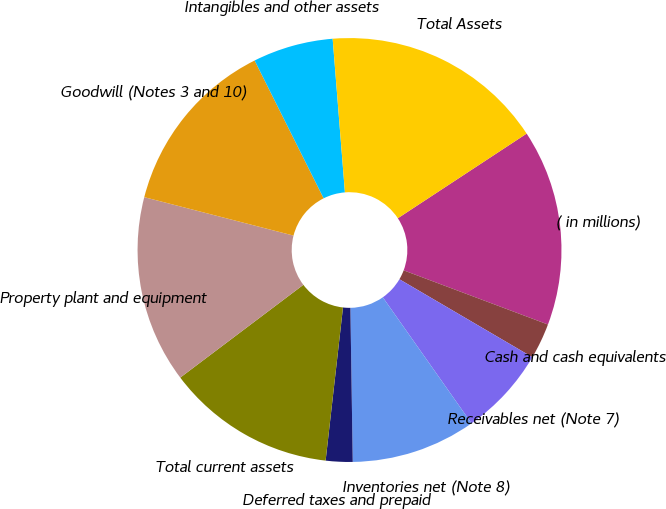<chart> <loc_0><loc_0><loc_500><loc_500><pie_chart><fcel>( in millions)<fcel>Cash and cash equivalents<fcel>Receivables net (Note 7)<fcel>Inventories net (Note 8)<fcel>Deferred taxes and prepaid<fcel>Total current assets<fcel>Property plant and equipment<fcel>Goodwill (Notes 3 and 10)<fcel>Intangibles and other assets<fcel>Total Assets<nl><fcel>14.97%<fcel>2.72%<fcel>6.8%<fcel>9.52%<fcel>2.04%<fcel>12.92%<fcel>14.29%<fcel>13.6%<fcel>6.12%<fcel>17.01%<nl></chart> 